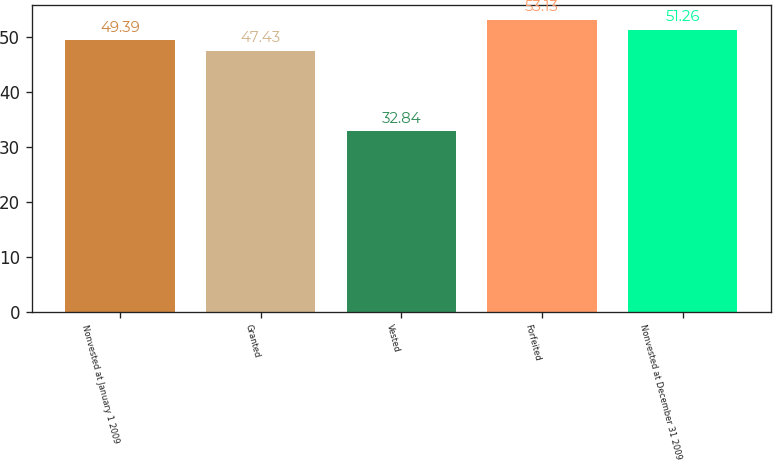Convert chart to OTSL. <chart><loc_0><loc_0><loc_500><loc_500><bar_chart><fcel>Nonvested at January 1 2009<fcel>Granted<fcel>Vested<fcel>Forfeited<fcel>Nonvested at December 31 2009<nl><fcel>49.39<fcel>47.43<fcel>32.84<fcel>53.13<fcel>51.26<nl></chart> 